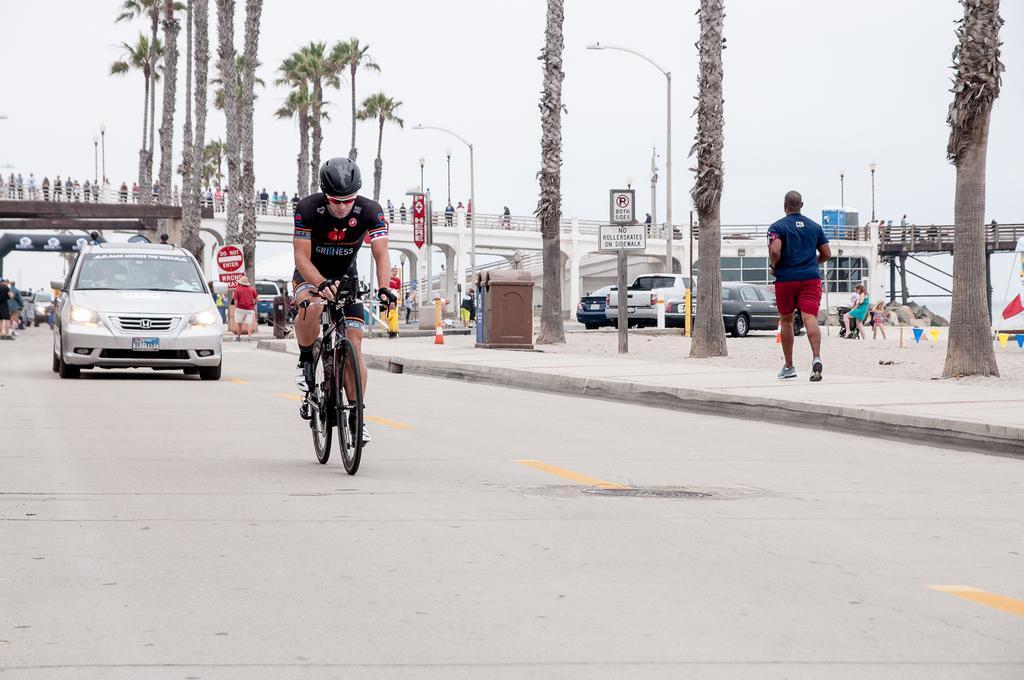Could you give a brief overview of what you see in this image? This picture is clicked outside the city. Here, we see man in black t-shirt who is wearing black color helmet is riding bicycle on the road. Behind him, we see a car moving on the road. Beside this man, we see a footpath on which man in blue t-shirt walking and in the middle of the picture, we see a bridge on which many people are moving. Behind this man, we see many trees. On the right corner of the picture, we see a building or a room. 